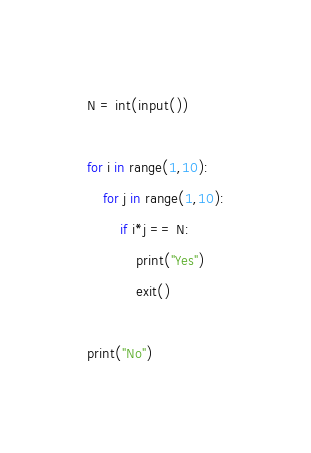<code> <loc_0><loc_0><loc_500><loc_500><_Python_>N = int(input())
 
for i in range(1,10):
    for j in range(1,10):
        if i*j == N:
            print("Yes")
            exit()
 
print("No")</code> 